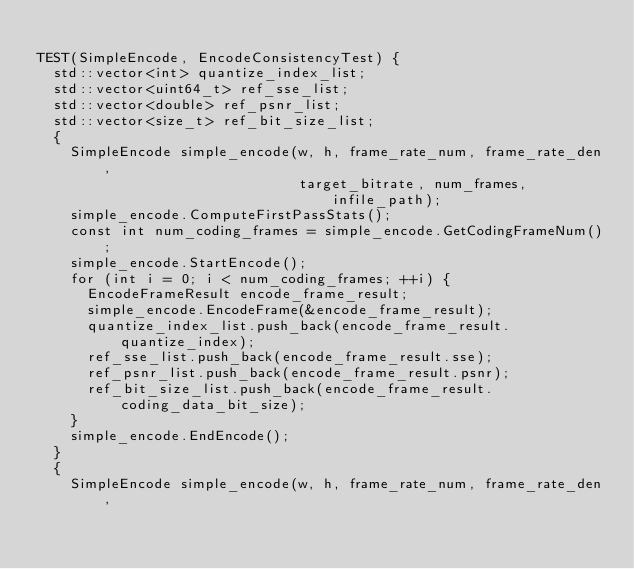<code> <loc_0><loc_0><loc_500><loc_500><_C++_>
TEST(SimpleEncode, EncodeConsistencyTest) {
  std::vector<int> quantize_index_list;
  std::vector<uint64_t> ref_sse_list;
  std::vector<double> ref_psnr_list;
  std::vector<size_t> ref_bit_size_list;
  {
    SimpleEncode simple_encode(w, h, frame_rate_num, frame_rate_den,
                               target_bitrate, num_frames, infile_path);
    simple_encode.ComputeFirstPassStats();
    const int num_coding_frames = simple_encode.GetCodingFrameNum();
    simple_encode.StartEncode();
    for (int i = 0; i < num_coding_frames; ++i) {
      EncodeFrameResult encode_frame_result;
      simple_encode.EncodeFrame(&encode_frame_result);
      quantize_index_list.push_back(encode_frame_result.quantize_index);
      ref_sse_list.push_back(encode_frame_result.sse);
      ref_psnr_list.push_back(encode_frame_result.psnr);
      ref_bit_size_list.push_back(encode_frame_result.coding_data_bit_size);
    }
    simple_encode.EndEncode();
  }
  {
    SimpleEncode simple_encode(w, h, frame_rate_num, frame_rate_den,</code> 